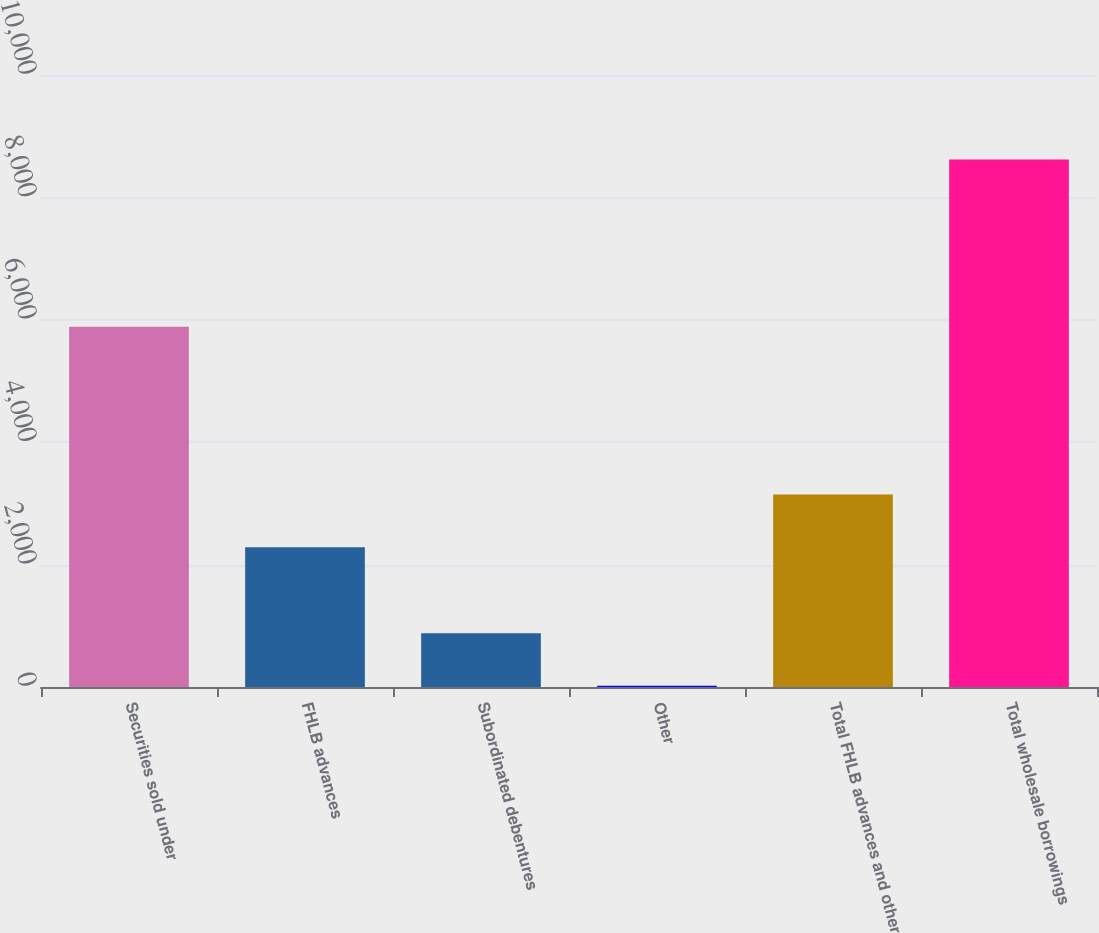Convert chart to OTSL. <chart><loc_0><loc_0><loc_500><loc_500><bar_chart><fcel>Securities sold under<fcel>FHLB advances<fcel>Subordinated debentures<fcel>Other<fcel>Total FHLB advances and other<fcel>Total wholesale borrowings<nl><fcel>5888.3<fcel>2284.1<fcel>880.09<fcel>20.1<fcel>3144.09<fcel>8620<nl></chart> 